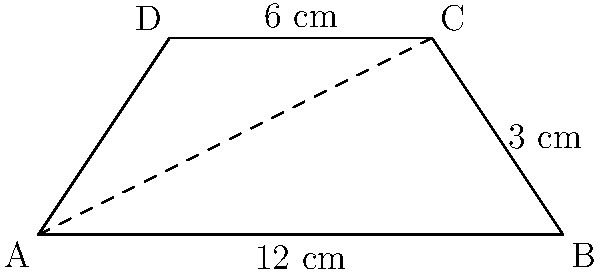Your granddaughter is learning about trapezoids in her geometry class. She shows you a diagram of a trapezoid ABCD, where the parallel sides are 12 cm and 6 cm long, and the height is 3 cm. Can you help her calculate the area of this trapezoid? Let's approach this step-by-step:

1) First, recall the formula for the area of a trapezoid:
   Area = $\frac{1}{2}(a+b)h$
   where $a$ and $b$ are the lengths of the parallel sides, and $h$ is the height.

2) In this case:
   $a = 12$ cm (the longer base)
   $b = 6$ cm (the shorter base)
   $h = 3$ cm (the height)

3) Now, let's substitute these values into our formula:
   Area = $\frac{1}{2}(12+6) \times 3$

4) First, add the bases:
   Area = $\frac{1}{2}(18) \times 3$

5) Multiply:
   Area = $9 \times 3 = 27$

Therefore, the area of the trapezoid is 27 square centimeters.
Answer: 27 cm² 